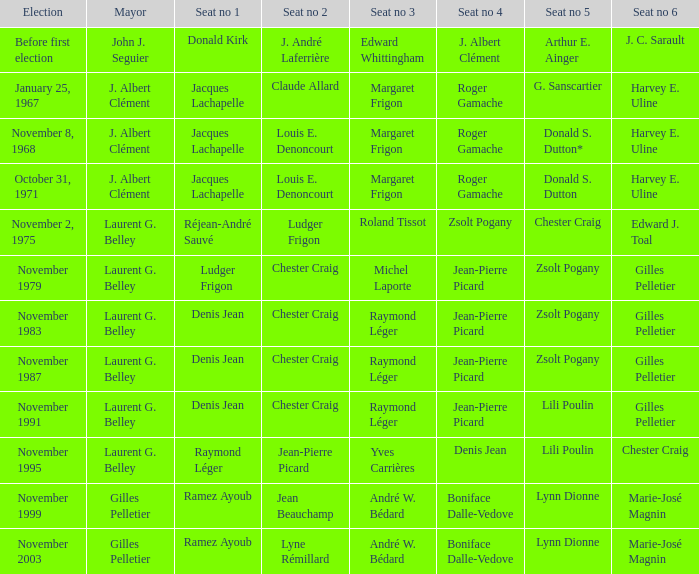Who is seat no 1 when the mayor was john j. seguier Donald Kirk. 